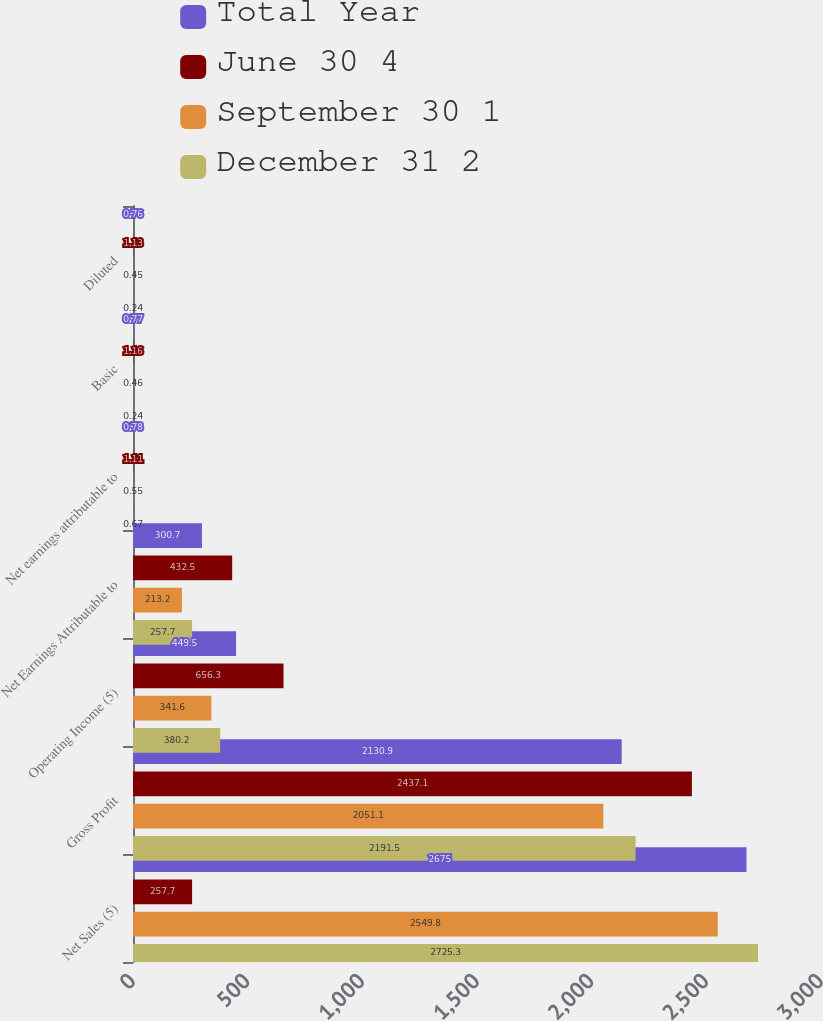Convert chart to OTSL. <chart><loc_0><loc_0><loc_500><loc_500><stacked_bar_chart><ecel><fcel>Net Sales (5)<fcel>Gross Profit<fcel>Operating Income (5)<fcel>Net Earnings Attributable to<fcel>Net earnings attributable to<fcel>Basic<fcel>Diluted<nl><fcel>Total Year<fcel>2675<fcel>2130.9<fcel>449.5<fcel>300.7<fcel>0.78<fcel>0.77<fcel>0.76<nl><fcel>June 30 4<fcel>257.7<fcel>2437.1<fcel>656.3<fcel>432.5<fcel>1.11<fcel>1.16<fcel>1.13<nl><fcel>September 30 1<fcel>2549.8<fcel>2051.1<fcel>341.6<fcel>213.2<fcel>0.55<fcel>0.46<fcel>0.45<nl><fcel>December 31 2<fcel>2725.3<fcel>2191.5<fcel>380.2<fcel>257.7<fcel>0.67<fcel>0.24<fcel>0.24<nl></chart> 